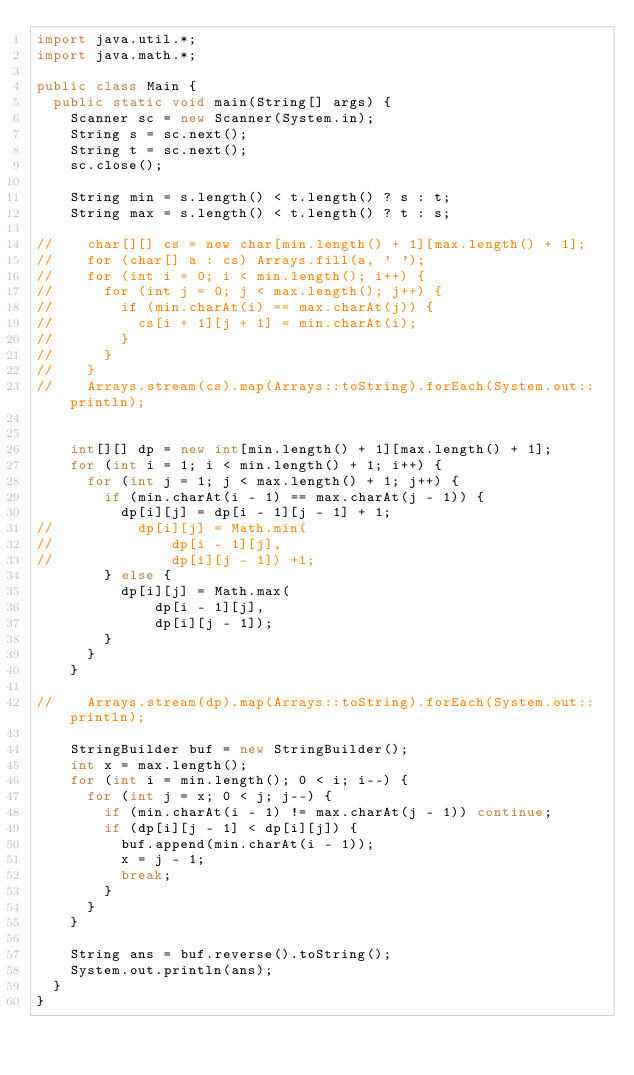<code> <loc_0><loc_0><loc_500><loc_500><_Java_>import java.util.*;
import java.math.*;

public class Main {
  public static void main(String[] args) {
    Scanner sc = new Scanner(System.in);
    String s = sc.next();
    String t = sc.next();
    sc.close();

    String min = s.length() < t.length() ? s : t;
    String max = s.length() < t.length() ? t : s;

//    char[][] cs = new char[min.length() + 1][max.length() + 1];
//    for (char[] a : cs) Arrays.fill(a, ' ');
//    for (int i = 0; i < min.length(); i++) {
//      for (int j = 0; j < max.length(); j++) {
//        if (min.charAt(i) == max.charAt(j)) {
//          cs[i + 1][j + 1] = min.charAt(i);
//        }
//      }
//    }
//    Arrays.stream(cs).map(Arrays::toString).forEach(System.out::println);


    int[][] dp = new int[min.length() + 1][max.length() + 1];
    for (int i = 1; i < min.length() + 1; i++) {
      for (int j = 1; j < max.length() + 1; j++) {
        if (min.charAt(i - 1) == max.charAt(j - 1)) {
          dp[i][j] = dp[i - 1][j - 1] + 1;
//          dp[i][j] = Math.min(
//              dp[i - 1][j],
//              dp[i][j - 1]) +1;
        } else {
          dp[i][j] = Math.max(
              dp[i - 1][j],
              dp[i][j - 1]);
        }
      }
    }

//    Arrays.stream(dp).map(Arrays::toString).forEach(System.out::println);

    StringBuilder buf = new StringBuilder();
    int x = max.length();
    for (int i = min.length(); 0 < i; i--) {
      for (int j = x; 0 < j; j--) {
        if (min.charAt(i - 1) != max.charAt(j - 1)) continue;
        if (dp[i][j - 1] < dp[i][j]) {
          buf.append(min.charAt(i - 1));
          x = j - 1;
          break;
        }
      }
    }

    String ans = buf.reverse().toString();
    System.out.println(ans);
  }
}</code> 